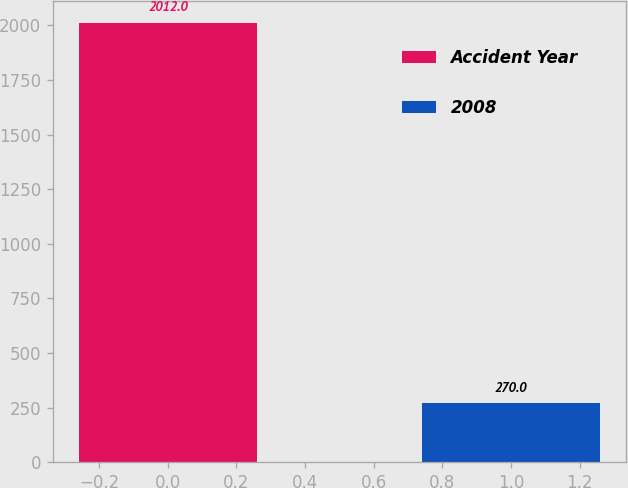Convert chart. <chart><loc_0><loc_0><loc_500><loc_500><bar_chart><fcel>Accident Year<fcel>2008<nl><fcel>2012<fcel>270<nl></chart> 